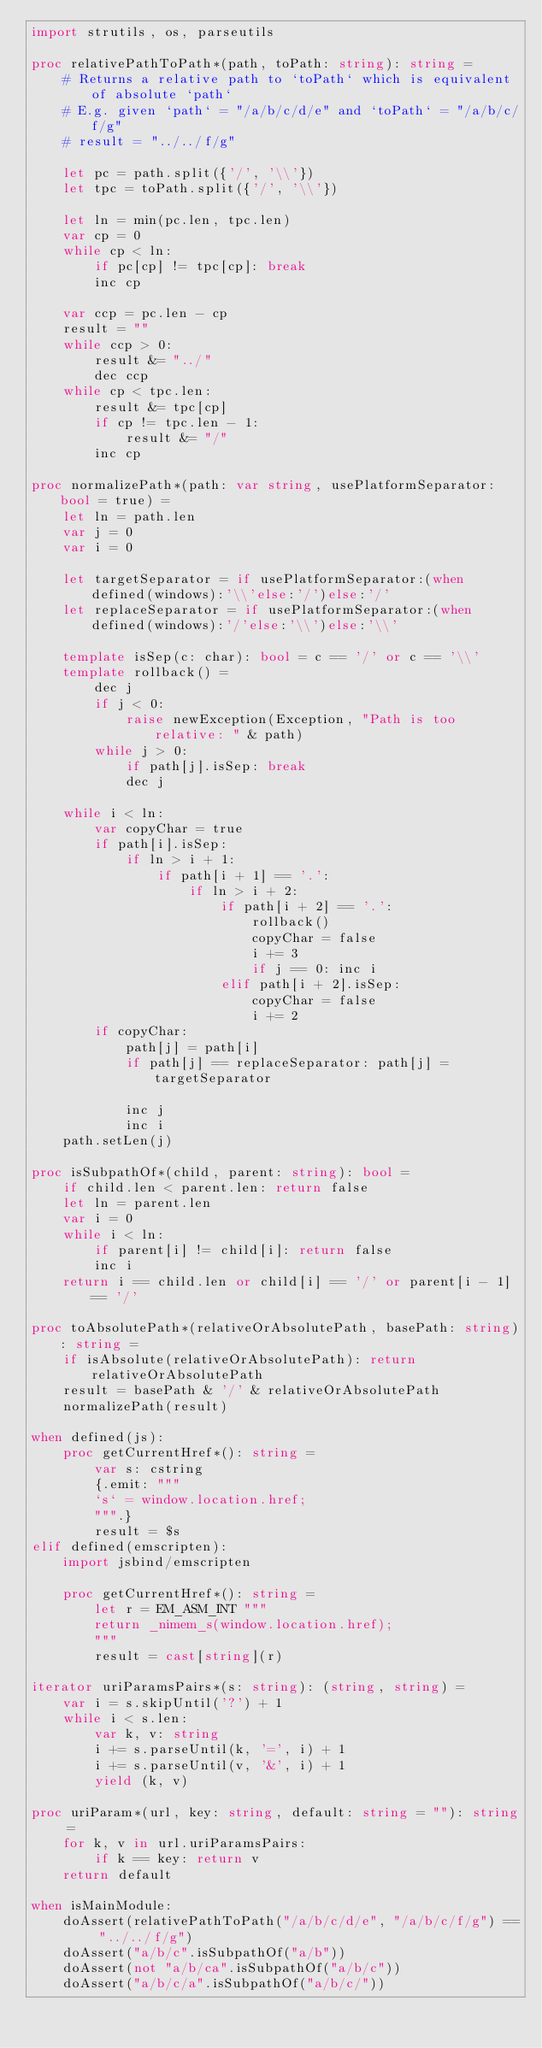Convert code to text. <code><loc_0><loc_0><loc_500><loc_500><_Nim_>import strutils, os, parseutils

proc relativePathToPath*(path, toPath: string): string =
    # Returns a relative path to `toPath` which is equivalent of absolute `path`
    # E.g. given `path` = "/a/b/c/d/e" and `toPath` = "/a/b/c/f/g"
    # result = "../../f/g"

    let pc = path.split({'/', '\\'})
    let tpc = toPath.split({'/', '\\'})

    let ln = min(pc.len, tpc.len)
    var cp = 0
    while cp < ln:
        if pc[cp] != tpc[cp]: break
        inc cp

    var ccp = pc.len - cp
    result = ""
    while ccp > 0:
        result &= "../"
        dec ccp
    while cp < tpc.len:
        result &= tpc[cp]
        if cp != tpc.len - 1:
            result &= "/"
        inc cp

proc normalizePath*(path: var string, usePlatformSeparator: bool = true) =
    let ln = path.len
    var j = 0
    var i = 0

    let targetSeparator = if usePlatformSeparator:(when defined(windows):'\\'else:'/')else:'/'
    let replaceSeparator = if usePlatformSeparator:(when defined(windows):'/'else:'\\')else:'\\'

    template isSep(c: char): bool = c == '/' or c == '\\'
    template rollback() =
        dec j
        if j < 0:
            raise newException(Exception, "Path is too relative: " & path)
        while j > 0:
            if path[j].isSep: break
            dec j

    while i < ln:
        var copyChar = true
        if path[i].isSep:
            if ln > i + 1:
                if path[i + 1] == '.':
                    if ln > i + 2:
                        if path[i + 2] == '.':
                            rollback()
                            copyChar = false
                            i += 3
                            if j == 0: inc i
                        elif path[i + 2].isSep:
                            copyChar = false
                            i += 2
        if copyChar:
            path[j] = path[i]
            if path[j] == replaceSeparator: path[j] = targetSeparator

            inc j
            inc i
    path.setLen(j)

proc isSubpathOf*(child, parent: string): bool =
    if child.len < parent.len: return false
    let ln = parent.len
    var i = 0
    while i < ln:
        if parent[i] != child[i]: return false
        inc i
    return i == child.len or child[i] == '/' or parent[i - 1] == '/'

proc toAbsolutePath*(relativeOrAbsolutePath, basePath: string): string =
    if isAbsolute(relativeOrAbsolutePath): return relativeOrAbsolutePath
    result = basePath & '/' & relativeOrAbsolutePath
    normalizePath(result)

when defined(js):
    proc getCurrentHref*(): string =
        var s: cstring
        {.emit: """
        `s` = window.location.href;
        """.}
        result = $s
elif defined(emscripten):
    import jsbind/emscripten

    proc getCurrentHref*(): string =
        let r = EM_ASM_INT """
        return _nimem_s(window.location.href);
        """
        result = cast[string](r)

iterator uriParamsPairs*(s: string): (string, string) =
    var i = s.skipUntil('?') + 1
    while i < s.len:
        var k, v: string
        i += s.parseUntil(k, '=', i) + 1
        i += s.parseUntil(v, '&', i) + 1
        yield (k, v)

proc uriParam*(url, key: string, default: string = ""): string =
    for k, v in url.uriParamsPairs:
        if k == key: return v
    return default

when isMainModule:
    doAssert(relativePathToPath("/a/b/c/d/e", "/a/b/c/f/g") == "../../f/g")
    doAssert("a/b/c".isSubpathOf("a/b"))
    doAssert(not "a/b/ca".isSubpathOf("a/b/c"))
    doAssert("a/b/c/a".isSubpathOf("a/b/c/"))
</code> 